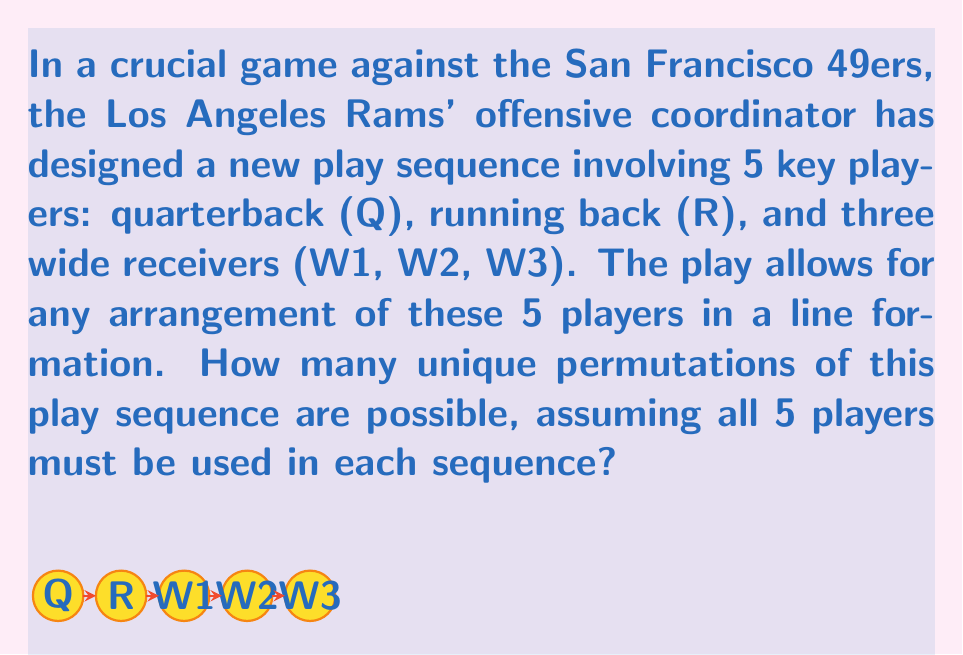Help me with this question. To solve this problem, we need to understand the concept of permutations in group theory:

1) We have 5 distinct players (Q, R, W1, W2, W3) that need to be arranged in a line.

2) This scenario represents a permutation of 5 elements, where the order matters (since it's a play sequence) and all elements must be used.

3) In group theory, this is represented by the symmetric group $S_5$, which contains all permutations of 5 elements.

4) The order of a permutation group is the number of elements in the group, which in this case is the number of possible permutations.

5) For n distinct elements, the number of permutations is given by n!

6) In this case, n = 5, so the number of permutations is:

   $5! = 5 \times 4 \times 3 \times 2 \times 1 = 120$

Therefore, there are 120 unique permutations of this play sequence possible.
Answer: 120 